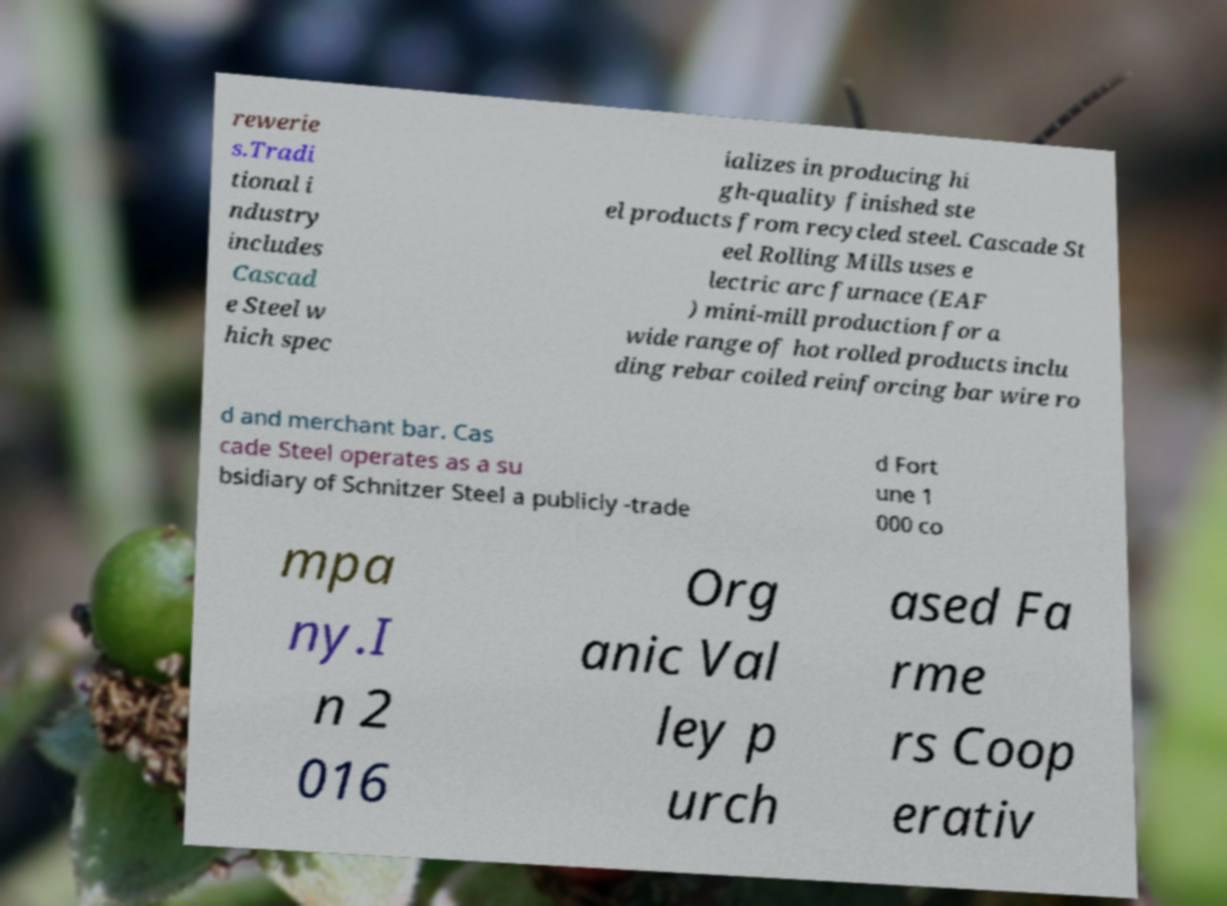Please identify and transcribe the text found in this image. rewerie s.Tradi tional i ndustry includes Cascad e Steel w hich spec ializes in producing hi gh-quality finished ste el products from recycled steel. Cascade St eel Rolling Mills uses e lectric arc furnace (EAF ) mini-mill production for a wide range of hot rolled products inclu ding rebar coiled reinforcing bar wire ro d and merchant bar. Cas cade Steel operates as a su bsidiary of Schnitzer Steel a publicly -trade d Fort une 1 000 co mpa ny.I n 2 016 Org anic Val ley p urch ased Fa rme rs Coop erativ 